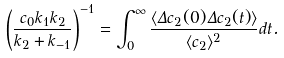<formula> <loc_0><loc_0><loc_500><loc_500>\left ( \frac { c _ { 0 } k _ { 1 } k _ { 2 } } { k _ { 2 } + k _ { - 1 } } \right ) ^ { - 1 } = \int _ { 0 } ^ { \infty } \frac { \langle \Delta c _ { 2 } ( 0 ) \Delta c _ { 2 } ( t ) \rangle } { \langle c _ { 2 } \rangle ^ { 2 } } d t .</formula> 